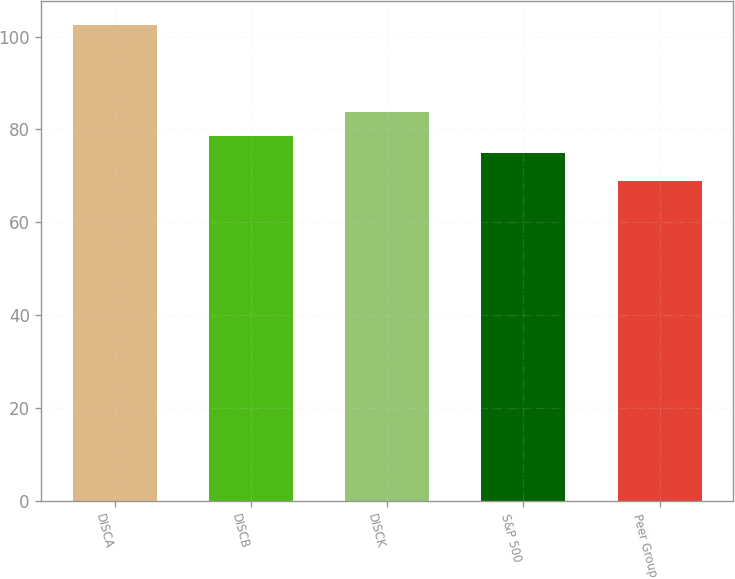<chart> <loc_0><loc_0><loc_500><loc_500><bar_chart><fcel>DISCA<fcel>DISCB<fcel>DISCK<fcel>S&P 500<fcel>Peer Group<nl><fcel>102.53<fcel>78.53<fcel>83.69<fcel>74.86<fcel>68.79<nl></chart> 